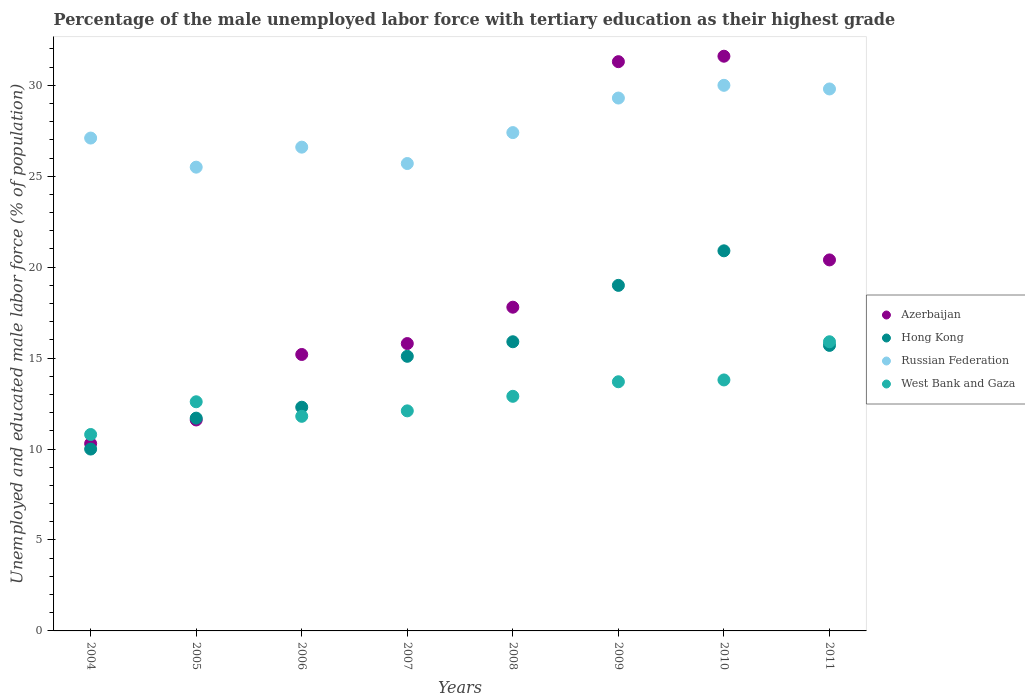Is the number of dotlines equal to the number of legend labels?
Offer a terse response. Yes. What is the percentage of the unemployed male labor force with tertiary education in Azerbaijan in 2011?
Your response must be concise. 20.4. Across all years, what is the maximum percentage of the unemployed male labor force with tertiary education in Hong Kong?
Make the answer very short. 20.9. In which year was the percentage of the unemployed male labor force with tertiary education in Hong Kong maximum?
Keep it short and to the point. 2010. What is the total percentage of the unemployed male labor force with tertiary education in Russian Federation in the graph?
Provide a succinct answer. 221.4. What is the difference between the percentage of the unemployed male labor force with tertiary education in Russian Federation in 2004 and that in 2011?
Your answer should be very brief. -2.7. What is the average percentage of the unemployed male labor force with tertiary education in West Bank and Gaza per year?
Your answer should be very brief. 12.95. In the year 2004, what is the difference between the percentage of the unemployed male labor force with tertiary education in Russian Federation and percentage of the unemployed male labor force with tertiary education in West Bank and Gaza?
Offer a very short reply. 16.3. In how many years, is the percentage of the unemployed male labor force with tertiary education in Hong Kong greater than 30 %?
Make the answer very short. 0. What is the ratio of the percentage of the unemployed male labor force with tertiary education in Azerbaijan in 2005 to that in 2008?
Offer a very short reply. 0.65. Is the percentage of the unemployed male labor force with tertiary education in Azerbaijan in 2010 less than that in 2011?
Your answer should be very brief. No. What is the difference between the highest and the second highest percentage of the unemployed male labor force with tertiary education in West Bank and Gaza?
Your answer should be very brief. 2.1. What is the difference between the highest and the lowest percentage of the unemployed male labor force with tertiary education in Hong Kong?
Your response must be concise. 10.9. In how many years, is the percentage of the unemployed male labor force with tertiary education in Hong Kong greater than the average percentage of the unemployed male labor force with tertiary education in Hong Kong taken over all years?
Make the answer very short. 5. Is the sum of the percentage of the unemployed male labor force with tertiary education in Russian Federation in 2004 and 2007 greater than the maximum percentage of the unemployed male labor force with tertiary education in Hong Kong across all years?
Make the answer very short. Yes. Is it the case that in every year, the sum of the percentage of the unemployed male labor force with tertiary education in Hong Kong and percentage of the unemployed male labor force with tertiary education in West Bank and Gaza  is greater than the percentage of the unemployed male labor force with tertiary education in Azerbaijan?
Make the answer very short. Yes. Does the percentage of the unemployed male labor force with tertiary education in Hong Kong monotonically increase over the years?
Offer a terse response. No. Is the percentage of the unemployed male labor force with tertiary education in West Bank and Gaza strictly less than the percentage of the unemployed male labor force with tertiary education in Azerbaijan over the years?
Your response must be concise. No. How many years are there in the graph?
Make the answer very short. 8. Does the graph contain grids?
Provide a short and direct response. No. How many legend labels are there?
Make the answer very short. 4. How are the legend labels stacked?
Your answer should be very brief. Vertical. What is the title of the graph?
Provide a succinct answer. Percentage of the male unemployed labor force with tertiary education as their highest grade. What is the label or title of the Y-axis?
Offer a terse response. Unemployed and educated male labor force (% of population). What is the Unemployed and educated male labor force (% of population) of Azerbaijan in 2004?
Give a very brief answer. 10.3. What is the Unemployed and educated male labor force (% of population) of Russian Federation in 2004?
Your answer should be very brief. 27.1. What is the Unemployed and educated male labor force (% of population) in West Bank and Gaza in 2004?
Your answer should be compact. 10.8. What is the Unemployed and educated male labor force (% of population) in Azerbaijan in 2005?
Provide a short and direct response. 11.6. What is the Unemployed and educated male labor force (% of population) of Hong Kong in 2005?
Keep it short and to the point. 11.7. What is the Unemployed and educated male labor force (% of population) of Russian Federation in 2005?
Keep it short and to the point. 25.5. What is the Unemployed and educated male labor force (% of population) in West Bank and Gaza in 2005?
Provide a succinct answer. 12.6. What is the Unemployed and educated male labor force (% of population) in Azerbaijan in 2006?
Give a very brief answer. 15.2. What is the Unemployed and educated male labor force (% of population) in Hong Kong in 2006?
Provide a short and direct response. 12.3. What is the Unemployed and educated male labor force (% of population) of Russian Federation in 2006?
Offer a very short reply. 26.6. What is the Unemployed and educated male labor force (% of population) of West Bank and Gaza in 2006?
Give a very brief answer. 11.8. What is the Unemployed and educated male labor force (% of population) of Azerbaijan in 2007?
Make the answer very short. 15.8. What is the Unemployed and educated male labor force (% of population) of Hong Kong in 2007?
Your answer should be very brief. 15.1. What is the Unemployed and educated male labor force (% of population) of Russian Federation in 2007?
Offer a very short reply. 25.7. What is the Unemployed and educated male labor force (% of population) in West Bank and Gaza in 2007?
Give a very brief answer. 12.1. What is the Unemployed and educated male labor force (% of population) in Azerbaijan in 2008?
Provide a short and direct response. 17.8. What is the Unemployed and educated male labor force (% of population) of Hong Kong in 2008?
Your response must be concise. 15.9. What is the Unemployed and educated male labor force (% of population) in Russian Federation in 2008?
Provide a succinct answer. 27.4. What is the Unemployed and educated male labor force (% of population) in West Bank and Gaza in 2008?
Your answer should be very brief. 12.9. What is the Unemployed and educated male labor force (% of population) of Azerbaijan in 2009?
Make the answer very short. 31.3. What is the Unemployed and educated male labor force (% of population) in Hong Kong in 2009?
Provide a short and direct response. 19. What is the Unemployed and educated male labor force (% of population) of Russian Federation in 2009?
Keep it short and to the point. 29.3. What is the Unemployed and educated male labor force (% of population) of West Bank and Gaza in 2009?
Keep it short and to the point. 13.7. What is the Unemployed and educated male labor force (% of population) of Azerbaijan in 2010?
Offer a very short reply. 31.6. What is the Unemployed and educated male labor force (% of population) of Hong Kong in 2010?
Your response must be concise. 20.9. What is the Unemployed and educated male labor force (% of population) in West Bank and Gaza in 2010?
Provide a succinct answer. 13.8. What is the Unemployed and educated male labor force (% of population) in Azerbaijan in 2011?
Provide a succinct answer. 20.4. What is the Unemployed and educated male labor force (% of population) in Hong Kong in 2011?
Offer a terse response. 15.7. What is the Unemployed and educated male labor force (% of population) in Russian Federation in 2011?
Make the answer very short. 29.8. What is the Unemployed and educated male labor force (% of population) in West Bank and Gaza in 2011?
Offer a terse response. 15.9. Across all years, what is the maximum Unemployed and educated male labor force (% of population) in Azerbaijan?
Provide a succinct answer. 31.6. Across all years, what is the maximum Unemployed and educated male labor force (% of population) of Hong Kong?
Your answer should be very brief. 20.9. Across all years, what is the maximum Unemployed and educated male labor force (% of population) in West Bank and Gaza?
Offer a terse response. 15.9. Across all years, what is the minimum Unemployed and educated male labor force (% of population) of Azerbaijan?
Give a very brief answer. 10.3. Across all years, what is the minimum Unemployed and educated male labor force (% of population) of Russian Federation?
Give a very brief answer. 25.5. Across all years, what is the minimum Unemployed and educated male labor force (% of population) of West Bank and Gaza?
Offer a terse response. 10.8. What is the total Unemployed and educated male labor force (% of population) of Azerbaijan in the graph?
Offer a terse response. 154. What is the total Unemployed and educated male labor force (% of population) of Hong Kong in the graph?
Your answer should be compact. 120.6. What is the total Unemployed and educated male labor force (% of population) of Russian Federation in the graph?
Give a very brief answer. 221.4. What is the total Unemployed and educated male labor force (% of population) of West Bank and Gaza in the graph?
Provide a succinct answer. 103.6. What is the difference between the Unemployed and educated male labor force (% of population) in Russian Federation in 2004 and that in 2005?
Provide a short and direct response. 1.6. What is the difference between the Unemployed and educated male labor force (% of population) of West Bank and Gaza in 2004 and that in 2005?
Make the answer very short. -1.8. What is the difference between the Unemployed and educated male labor force (% of population) in Azerbaijan in 2004 and that in 2006?
Give a very brief answer. -4.9. What is the difference between the Unemployed and educated male labor force (% of population) of Hong Kong in 2004 and that in 2006?
Your response must be concise. -2.3. What is the difference between the Unemployed and educated male labor force (% of population) of Russian Federation in 2004 and that in 2006?
Make the answer very short. 0.5. What is the difference between the Unemployed and educated male labor force (% of population) in Azerbaijan in 2004 and that in 2007?
Give a very brief answer. -5.5. What is the difference between the Unemployed and educated male labor force (% of population) of Russian Federation in 2004 and that in 2007?
Your answer should be very brief. 1.4. What is the difference between the Unemployed and educated male labor force (% of population) in West Bank and Gaza in 2004 and that in 2007?
Give a very brief answer. -1.3. What is the difference between the Unemployed and educated male labor force (% of population) in Russian Federation in 2004 and that in 2008?
Provide a short and direct response. -0.3. What is the difference between the Unemployed and educated male labor force (% of population) in Azerbaijan in 2004 and that in 2009?
Provide a succinct answer. -21. What is the difference between the Unemployed and educated male labor force (% of population) of Hong Kong in 2004 and that in 2009?
Your answer should be compact. -9. What is the difference between the Unemployed and educated male labor force (% of population) in Russian Federation in 2004 and that in 2009?
Your answer should be compact. -2.2. What is the difference between the Unemployed and educated male labor force (% of population) in West Bank and Gaza in 2004 and that in 2009?
Keep it short and to the point. -2.9. What is the difference between the Unemployed and educated male labor force (% of population) in Azerbaijan in 2004 and that in 2010?
Offer a terse response. -21.3. What is the difference between the Unemployed and educated male labor force (% of population) in Russian Federation in 2004 and that in 2010?
Your response must be concise. -2.9. What is the difference between the Unemployed and educated male labor force (% of population) in West Bank and Gaza in 2004 and that in 2010?
Keep it short and to the point. -3. What is the difference between the Unemployed and educated male labor force (% of population) of Azerbaijan in 2004 and that in 2011?
Give a very brief answer. -10.1. What is the difference between the Unemployed and educated male labor force (% of population) of West Bank and Gaza in 2004 and that in 2011?
Your answer should be very brief. -5.1. What is the difference between the Unemployed and educated male labor force (% of population) in Russian Federation in 2005 and that in 2006?
Provide a short and direct response. -1.1. What is the difference between the Unemployed and educated male labor force (% of population) in Azerbaijan in 2005 and that in 2007?
Offer a terse response. -4.2. What is the difference between the Unemployed and educated male labor force (% of population) of Hong Kong in 2005 and that in 2008?
Offer a very short reply. -4.2. What is the difference between the Unemployed and educated male labor force (% of population) of Russian Federation in 2005 and that in 2008?
Give a very brief answer. -1.9. What is the difference between the Unemployed and educated male labor force (% of population) of West Bank and Gaza in 2005 and that in 2008?
Ensure brevity in your answer.  -0.3. What is the difference between the Unemployed and educated male labor force (% of population) in Azerbaijan in 2005 and that in 2009?
Ensure brevity in your answer.  -19.7. What is the difference between the Unemployed and educated male labor force (% of population) in West Bank and Gaza in 2005 and that in 2009?
Keep it short and to the point. -1.1. What is the difference between the Unemployed and educated male labor force (% of population) in Hong Kong in 2005 and that in 2010?
Provide a succinct answer. -9.2. What is the difference between the Unemployed and educated male labor force (% of population) of Hong Kong in 2005 and that in 2011?
Give a very brief answer. -4. What is the difference between the Unemployed and educated male labor force (% of population) of Russian Federation in 2005 and that in 2011?
Your answer should be compact. -4.3. What is the difference between the Unemployed and educated male labor force (% of population) in Russian Federation in 2006 and that in 2007?
Ensure brevity in your answer.  0.9. What is the difference between the Unemployed and educated male labor force (% of population) in West Bank and Gaza in 2006 and that in 2007?
Provide a succinct answer. -0.3. What is the difference between the Unemployed and educated male labor force (% of population) of Hong Kong in 2006 and that in 2008?
Provide a short and direct response. -3.6. What is the difference between the Unemployed and educated male labor force (% of population) of Russian Federation in 2006 and that in 2008?
Offer a very short reply. -0.8. What is the difference between the Unemployed and educated male labor force (% of population) in Azerbaijan in 2006 and that in 2009?
Your response must be concise. -16.1. What is the difference between the Unemployed and educated male labor force (% of population) in West Bank and Gaza in 2006 and that in 2009?
Your response must be concise. -1.9. What is the difference between the Unemployed and educated male labor force (% of population) of Azerbaijan in 2006 and that in 2010?
Offer a terse response. -16.4. What is the difference between the Unemployed and educated male labor force (% of population) of Hong Kong in 2006 and that in 2010?
Your answer should be compact. -8.6. What is the difference between the Unemployed and educated male labor force (% of population) in Russian Federation in 2006 and that in 2010?
Your answer should be very brief. -3.4. What is the difference between the Unemployed and educated male labor force (% of population) of West Bank and Gaza in 2006 and that in 2010?
Offer a very short reply. -2. What is the difference between the Unemployed and educated male labor force (% of population) in Azerbaijan in 2006 and that in 2011?
Offer a terse response. -5.2. What is the difference between the Unemployed and educated male labor force (% of population) in Hong Kong in 2006 and that in 2011?
Your answer should be very brief. -3.4. What is the difference between the Unemployed and educated male labor force (% of population) in Russian Federation in 2006 and that in 2011?
Provide a succinct answer. -3.2. What is the difference between the Unemployed and educated male labor force (% of population) in West Bank and Gaza in 2006 and that in 2011?
Offer a terse response. -4.1. What is the difference between the Unemployed and educated male labor force (% of population) in Azerbaijan in 2007 and that in 2008?
Offer a very short reply. -2. What is the difference between the Unemployed and educated male labor force (% of population) in Hong Kong in 2007 and that in 2008?
Keep it short and to the point. -0.8. What is the difference between the Unemployed and educated male labor force (% of population) in West Bank and Gaza in 2007 and that in 2008?
Your answer should be compact. -0.8. What is the difference between the Unemployed and educated male labor force (% of population) in Azerbaijan in 2007 and that in 2009?
Give a very brief answer. -15.5. What is the difference between the Unemployed and educated male labor force (% of population) in West Bank and Gaza in 2007 and that in 2009?
Keep it short and to the point. -1.6. What is the difference between the Unemployed and educated male labor force (% of population) in Azerbaijan in 2007 and that in 2010?
Provide a short and direct response. -15.8. What is the difference between the Unemployed and educated male labor force (% of population) in Russian Federation in 2007 and that in 2011?
Offer a very short reply. -4.1. What is the difference between the Unemployed and educated male labor force (% of population) in Azerbaijan in 2008 and that in 2009?
Your answer should be compact. -13.5. What is the difference between the Unemployed and educated male labor force (% of population) in Hong Kong in 2008 and that in 2009?
Give a very brief answer. -3.1. What is the difference between the Unemployed and educated male labor force (% of population) of Hong Kong in 2008 and that in 2010?
Keep it short and to the point. -5. What is the difference between the Unemployed and educated male labor force (% of population) of Russian Federation in 2008 and that in 2010?
Your answer should be compact. -2.6. What is the difference between the Unemployed and educated male labor force (% of population) of West Bank and Gaza in 2008 and that in 2010?
Make the answer very short. -0.9. What is the difference between the Unemployed and educated male labor force (% of population) in Hong Kong in 2008 and that in 2011?
Make the answer very short. 0.2. What is the difference between the Unemployed and educated male labor force (% of population) in Hong Kong in 2009 and that in 2010?
Your answer should be compact. -1.9. What is the difference between the Unemployed and educated male labor force (% of population) of Russian Federation in 2009 and that in 2010?
Make the answer very short. -0.7. What is the difference between the Unemployed and educated male labor force (% of population) in West Bank and Gaza in 2009 and that in 2010?
Ensure brevity in your answer.  -0.1. What is the difference between the Unemployed and educated male labor force (% of population) in Azerbaijan in 2009 and that in 2011?
Your answer should be very brief. 10.9. What is the difference between the Unemployed and educated male labor force (% of population) in Hong Kong in 2009 and that in 2011?
Provide a succinct answer. 3.3. What is the difference between the Unemployed and educated male labor force (% of population) in Russian Federation in 2009 and that in 2011?
Your answer should be compact. -0.5. What is the difference between the Unemployed and educated male labor force (% of population) of Azerbaijan in 2010 and that in 2011?
Your response must be concise. 11.2. What is the difference between the Unemployed and educated male labor force (% of population) in Russian Federation in 2010 and that in 2011?
Your response must be concise. 0.2. What is the difference between the Unemployed and educated male labor force (% of population) in West Bank and Gaza in 2010 and that in 2011?
Make the answer very short. -2.1. What is the difference between the Unemployed and educated male labor force (% of population) in Azerbaijan in 2004 and the Unemployed and educated male labor force (% of population) in Hong Kong in 2005?
Offer a terse response. -1.4. What is the difference between the Unemployed and educated male labor force (% of population) of Azerbaijan in 2004 and the Unemployed and educated male labor force (% of population) of Russian Federation in 2005?
Keep it short and to the point. -15.2. What is the difference between the Unemployed and educated male labor force (% of population) of Hong Kong in 2004 and the Unemployed and educated male labor force (% of population) of Russian Federation in 2005?
Provide a succinct answer. -15.5. What is the difference between the Unemployed and educated male labor force (% of population) in Hong Kong in 2004 and the Unemployed and educated male labor force (% of population) in West Bank and Gaza in 2005?
Your response must be concise. -2.6. What is the difference between the Unemployed and educated male labor force (% of population) in Russian Federation in 2004 and the Unemployed and educated male labor force (% of population) in West Bank and Gaza in 2005?
Your answer should be very brief. 14.5. What is the difference between the Unemployed and educated male labor force (% of population) in Azerbaijan in 2004 and the Unemployed and educated male labor force (% of population) in Hong Kong in 2006?
Offer a very short reply. -2. What is the difference between the Unemployed and educated male labor force (% of population) of Azerbaijan in 2004 and the Unemployed and educated male labor force (% of population) of Russian Federation in 2006?
Your answer should be compact. -16.3. What is the difference between the Unemployed and educated male labor force (% of population) of Azerbaijan in 2004 and the Unemployed and educated male labor force (% of population) of West Bank and Gaza in 2006?
Your response must be concise. -1.5. What is the difference between the Unemployed and educated male labor force (% of population) in Hong Kong in 2004 and the Unemployed and educated male labor force (% of population) in Russian Federation in 2006?
Ensure brevity in your answer.  -16.6. What is the difference between the Unemployed and educated male labor force (% of population) in Azerbaijan in 2004 and the Unemployed and educated male labor force (% of population) in Russian Federation in 2007?
Make the answer very short. -15.4. What is the difference between the Unemployed and educated male labor force (% of population) of Azerbaijan in 2004 and the Unemployed and educated male labor force (% of population) of West Bank and Gaza in 2007?
Offer a terse response. -1.8. What is the difference between the Unemployed and educated male labor force (% of population) of Hong Kong in 2004 and the Unemployed and educated male labor force (% of population) of Russian Federation in 2007?
Your answer should be very brief. -15.7. What is the difference between the Unemployed and educated male labor force (% of population) in Hong Kong in 2004 and the Unemployed and educated male labor force (% of population) in West Bank and Gaza in 2007?
Offer a terse response. -2.1. What is the difference between the Unemployed and educated male labor force (% of population) in Azerbaijan in 2004 and the Unemployed and educated male labor force (% of population) in Russian Federation in 2008?
Provide a short and direct response. -17.1. What is the difference between the Unemployed and educated male labor force (% of population) in Hong Kong in 2004 and the Unemployed and educated male labor force (% of population) in Russian Federation in 2008?
Provide a short and direct response. -17.4. What is the difference between the Unemployed and educated male labor force (% of population) in Hong Kong in 2004 and the Unemployed and educated male labor force (% of population) in West Bank and Gaza in 2008?
Make the answer very short. -2.9. What is the difference between the Unemployed and educated male labor force (% of population) of Azerbaijan in 2004 and the Unemployed and educated male labor force (% of population) of Russian Federation in 2009?
Give a very brief answer. -19. What is the difference between the Unemployed and educated male labor force (% of population) in Hong Kong in 2004 and the Unemployed and educated male labor force (% of population) in Russian Federation in 2009?
Offer a very short reply. -19.3. What is the difference between the Unemployed and educated male labor force (% of population) in Russian Federation in 2004 and the Unemployed and educated male labor force (% of population) in West Bank and Gaza in 2009?
Provide a short and direct response. 13.4. What is the difference between the Unemployed and educated male labor force (% of population) in Azerbaijan in 2004 and the Unemployed and educated male labor force (% of population) in Hong Kong in 2010?
Give a very brief answer. -10.6. What is the difference between the Unemployed and educated male labor force (% of population) in Azerbaijan in 2004 and the Unemployed and educated male labor force (% of population) in Russian Federation in 2010?
Offer a terse response. -19.7. What is the difference between the Unemployed and educated male labor force (% of population) of Azerbaijan in 2004 and the Unemployed and educated male labor force (% of population) of West Bank and Gaza in 2010?
Provide a succinct answer. -3.5. What is the difference between the Unemployed and educated male labor force (% of population) of Hong Kong in 2004 and the Unemployed and educated male labor force (% of population) of Russian Federation in 2010?
Keep it short and to the point. -20. What is the difference between the Unemployed and educated male labor force (% of population) of Azerbaijan in 2004 and the Unemployed and educated male labor force (% of population) of Russian Federation in 2011?
Offer a terse response. -19.5. What is the difference between the Unemployed and educated male labor force (% of population) of Hong Kong in 2004 and the Unemployed and educated male labor force (% of population) of Russian Federation in 2011?
Ensure brevity in your answer.  -19.8. What is the difference between the Unemployed and educated male labor force (% of population) of Russian Federation in 2004 and the Unemployed and educated male labor force (% of population) of West Bank and Gaza in 2011?
Ensure brevity in your answer.  11.2. What is the difference between the Unemployed and educated male labor force (% of population) of Azerbaijan in 2005 and the Unemployed and educated male labor force (% of population) of West Bank and Gaza in 2006?
Ensure brevity in your answer.  -0.2. What is the difference between the Unemployed and educated male labor force (% of population) of Hong Kong in 2005 and the Unemployed and educated male labor force (% of population) of Russian Federation in 2006?
Your answer should be very brief. -14.9. What is the difference between the Unemployed and educated male labor force (% of population) in Hong Kong in 2005 and the Unemployed and educated male labor force (% of population) in West Bank and Gaza in 2006?
Ensure brevity in your answer.  -0.1. What is the difference between the Unemployed and educated male labor force (% of population) in Azerbaijan in 2005 and the Unemployed and educated male labor force (% of population) in Hong Kong in 2007?
Make the answer very short. -3.5. What is the difference between the Unemployed and educated male labor force (% of population) of Azerbaijan in 2005 and the Unemployed and educated male labor force (% of population) of Russian Federation in 2007?
Your answer should be compact. -14.1. What is the difference between the Unemployed and educated male labor force (% of population) of Azerbaijan in 2005 and the Unemployed and educated male labor force (% of population) of West Bank and Gaza in 2007?
Provide a succinct answer. -0.5. What is the difference between the Unemployed and educated male labor force (% of population) of Azerbaijan in 2005 and the Unemployed and educated male labor force (% of population) of Hong Kong in 2008?
Keep it short and to the point. -4.3. What is the difference between the Unemployed and educated male labor force (% of population) in Azerbaijan in 2005 and the Unemployed and educated male labor force (% of population) in Russian Federation in 2008?
Offer a very short reply. -15.8. What is the difference between the Unemployed and educated male labor force (% of population) of Azerbaijan in 2005 and the Unemployed and educated male labor force (% of population) of West Bank and Gaza in 2008?
Provide a succinct answer. -1.3. What is the difference between the Unemployed and educated male labor force (% of population) in Hong Kong in 2005 and the Unemployed and educated male labor force (% of population) in Russian Federation in 2008?
Offer a very short reply. -15.7. What is the difference between the Unemployed and educated male labor force (% of population) in Azerbaijan in 2005 and the Unemployed and educated male labor force (% of population) in Russian Federation in 2009?
Provide a short and direct response. -17.7. What is the difference between the Unemployed and educated male labor force (% of population) of Azerbaijan in 2005 and the Unemployed and educated male labor force (% of population) of West Bank and Gaza in 2009?
Your answer should be compact. -2.1. What is the difference between the Unemployed and educated male labor force (% of population) in Hong Kong in 2005 and the Unemployed and educated male labor force (% of population) in Russian Federation in 2009?
Provide a short and direct response. -17.6. What is the difference between the Unemployed and educated male labor force (% of population) in Hong Kong in 2005 and the Unemployed and educated male labor force (% of population) in West Bank and Gaza in 2009?
Offer a very short reply. -2. What is the difference between the Unemployed and educated male labor force (% of population) in Russian Federation in 2005 and the Unemployed and educated male labor force (% of population) in West Bank and Gaza in 2009?
Offer a terse response. 11.8. What is the difference between the Unemployed and educated male labor force (% of population) in Azerbaijan in 2005 and the Unemployed and educated male labor force (% of population) in Hong Kong in 2010?
Provide a short and direct response. -9.3. What is the difference between the Unemployed and educated male labor force (% of population) in Azerbaijan in 2005 and the Unemployed and educated male labor force (% of population) in Russian Federation in 2010?
Your answer should be very brief. -18.4. What is the difference between the Unemployed and educated male labor force (% of population) of Azerbaijan in 2005 and the Unemployed and educated male labor force (% of population) of West Bank and Gaza in 2010?
Offer a terse response. -2.2. What is the difference between the Unemployed and educated male labor force (% of population) in Hong Kong in 2005 and the Unemployed and educated male labor force (% of population) in Russian Federation in 2010?
Provide a short and direct response. -18.3. What is the difference between the Unemployed and educated male labor force (% of population) of Russian Federation in 2005 and the Unemployed and educated male labor force (% of population) of West Bank and Gaza in 2010?
Keep it short and to the point. 11.7. What is the difference between the Unemployed and educated male labor force (% of population) of Azerbaijan in 2005 and the Unemployed and educated male labor force (% of population) of Hong Kong in 2011?
Offer a terse response. -4.1. What is the difference between the Unemployed and educated male labor force (% of population) in Azerbaijan in 2005 and the Unemployed and educated male labor force (% of population) in Russian Federation in 2011?
Your response must be concise. -18.2. What is the difference between the Unemployed and educated male labor force (% of population) in Hong Kong in 2005 and the Unemployed and educated male labor force (% of population) in Russian Federation in 2011?
Your answer should be compact. -18.1. What is the difference between the Unemployed and educated male labor force (% of population) of Hong Kong in 2005 and the Unemployed and educated male labor force (% of population) of West Bank and Gaza in 2011?
Make the answer very short. -4.2. What is the difference between the Unemployed and educated male labor force (% of population) of Azerbaijan in 2006 and the Unemployed and educated male labor force (% of population) of Hong Kong in 2007?
Your response must be concise. 0.1. What is the difference between the Unemployed and educated male labor force (% of population) in Azerbaijan in 2006 and the Unemployed and educated male labor force (% of population) in Russian Federation in 2007?
Provide a succinct answer. -10.5. What is the difference between the Unemployed and educated male labor force (% of population) of Azerbaijan in 2006 and the Unemployed and educated male labor force (% of population) of West Bank and Gaza in 2007?
Your answer should be very brief. 3.1. What is the difference between the Unemployed and educated male labor force (% of population) of Hong Kong in 2006 and the Unemployed and educated male labor force (% of population) of Russian Federation in 2007?
Offer a terse response. -13.4. What is the difference between the Unemployed and educated male labor force (% of population) of Russian Federation in 2006 and the Unemployed and educated male labor force (% of population) of West Bank and Gaza in 2007?
Make the answer very short. 14.5. What is the difference between the Unemployed and educated male labor force (% of population) of Azerbaijan in 2006 and the Unemployed and educated male labor force (% of population) of Hong Kong in 2008?
Provide a succinct answer. -0.7. What is the difference between the Unemployed and educated male labor force (% of population) of Hong Kong in 2006 and the Unemployed and educated male labor force (% of population) of Russian Federation in 2008?
Your answer should be very brief. -15.1. What is the difference between the Unemployed and educated male labor force (% of population) in Hong Kong in 2006 and the Unemployed and educated male labor force (% of population) in West Bank and Gaza in 2008?
Offer a very short reply. -0.6. What is the difference between the Unemployed and educated male labor force (% of population) in Azerbaijan in 2006 and the Unemployed and educated male labor force (% of population) in Hong Kong in 2009?
Your answer should be compact. -3.8. What is the difference between the Unemployed and educated male labor force (% of population) in Azerbaijan in 2006 and the Unemployed and educated male labor force (% of population) in Russian Federation in 2009?
Your answer should be very brief. -14.1. What is the difference between the Unemployed and educated male labor force (% of population) in Azerbaijan in 2006 and the Unemployed and educated male labor force (% of population) in West Bank and Gaza in 2009?
Your answer should be compact. 1.5. What is the difference between the Unemployed and educated male labor force (% of population) in Russian Federation in 2006 and the Unemployed and educated male labor force (% of population) in West Bank and Gaza in 2009?
Your answer should be compact. 12.9. What is the difference between the Unemployed and educated male labor force (% of population) in Azerbaijan in 2006 and the Unemployed and educated male labor force (% of population) in Russian Federation in 2010?
Provide a short and direct response. -14.8. What is the difference between the Unemployed and educated male labor force (% of population) of Azerbaijan in 2006 and the Unemployed and educated male labor force (% of population) of West Bank and Gaza in 2010?
Give a very brief answer. 1.4. What is the difference between the Unemployed and educated male labor force (% of population) in Hong Kong in 2006 and the Unemployed and educated male labor force (% of population) in Russian Federation in 2010?
Your answer should be very brief. -17.7. What is the difference between the Unemployed and educated male labor force (% of population) in Hong Kong in 2006 and the Unemployed and educated male labor force (% of population) in West Bank and Gaza in 2010?
Your answer should be compact. -1.5. What is the difference between the Unemployed and educated male labor force (% of population) of Azerbaijan in 2006 and the Unemployed and educated male labor force (% of population) of Russian Federation in 2011?
Offer a very short reply. -14.6. What is the difference between the Unemployed and educated male labor force (% of population) in Hong Kong in 2006 and the Unemployed and educated male labor force (% of population) in Russian Federation in 2011?
Your answer should be very brief. -17.5. What is the difference between the Unemployed and educated male labor force (% of population) in Russian Federation in 2006 and the Unemployed and educated male labor force (% of population) in West Bank and Gaza in 2011?
Give a very brief answer. 10.7. What is the difference between the Unemployed and educated male labor force (% of population) in Azerbaijan in 2007 and the Unemployed and educated male labor force (% of population) in Hong Kong in 2008?
Offer a terse response. -0.1. What is the difference between the Unemployed and educated male labor force (% of population) in Azerbaijan in 2007 and the Unemployed and educated male labor force (% of population) in West Bank and Gaza in 2008?
Your answer should be compact. 2.9. What is the difference between the Unemployed and educated male labor force (% of population) in Hong Kong in 2007 and the Unemployed and educated male labor force (% of population) in Russian Federation in 2008?
Provide a succinct answer. -12.3. What is the difference between the Unemployed and educated male labor force (% of population) in Azerbaijan in 2007 and the Unemployed and educated male labor force (% of population) in Hong Kong in 2009?
Give a very brief answer. -3.2. What is the difference between the Unemployed and educated male labor force (% of population) in Hong Kong in 2007 and the Unemployed and educated male labor force (% of population) in West Bank and Gaza in 2009?
Your answer should be compact. 1.4. What is the difference between the Unemployed and educated male labor force (% of population) in Russian Federation in 2007 and the Unemployed and educated male labor force (% of population) in West Bank and Gaza in 2009?
Make the answer very short. 12. What is the difference between the Unemployed and educated male labor force (% of population) in Azerbaijan in 2007 and the Unemployed and educated male labor force (% of population) in Hong Kong in 2010?
Make the answer very short. -5.1. What is the difference between the Unemployed and educated male labor force (% of population) in Azerbaijan in 2007 and the Unemployed and educated male labor force (% of population) in West Bank and Gaza in 2010?
Keep it short and to the point. 2. What is the difference between the Unemployed and educated male labor force (% of population) in Hong Kong in 2007 and the Unemployed and educated male labor force (% of population) in Russian Federation in 2010?
Provide a short and direct response. -14.9. What is the difference between the Unemployed and educated male labor force (% of population) in Hong Kong in 2007 and the Unemployed and educated male labor force (% of population) in West Bank and Gaza in 2010?
Ensure brevity in your answer.  1.3. What is the difference between the Unemployed and educated male labor force (% of population) in Russian Federation in 2007 and the Unemployed and educated male labor force (% of population) in West Bank and Gaza in 2010?
Offer a very short reply. 11.9. What is the difference between the Unemployed and educated male labor force (% of population) in Azerbaijan in 2007 and the Unemployed and educated male labor force (% of population) in Russian Federation in 2011?
Your answer should be compact. -14. What is the difference between the Unemployed and educated male labor force (% of population) in Azerbaijan in 2007 and the Unemployed and educated male labor force (% of population) in West Bank and Gaza in 2011?
Your answer should be very brief. -0.1. What is the difference between the Unemployed and educated male labor force (% of population) in Hong Kong in 2007 and the Unemployed and educated male labor force (% of population) in Russian Federation in 2011?
Make the answer very short. -14.7. What is the difference between the Unemployed and educated male labor force (% of population) of Azerbaijan in 2008 and the Unemployed and educated male labor force (% of population) of Russian Federation in 2009?
Make the answer very short. -11.5. What is the difference between the Unemployed and educated male labor force (% of population) in Azerbaijan in 2008 and the Unemployed and educated male labor force (% of population) in West Bank and Gaza in 2009?
Your response must be concise. 4.1. What is the difference between the Unemployed and educated male labor force (% of population) in Hong Kong in 2008 and the Unemployed and educated male labor force (% of population) in Russian Federation in 2009?
Provide a succinct answer. -13.4. What is the difference between the Unemployed and educated male labor force (% of population) of Hong Kong in 2008 and the Unemployed and educated male labor force (% of population) of West Bank and Gaza in 2009?
Offer a terse response. 2.2. What is the difference between the Unemployed and educated male labor force (% of population) of Russian Federation in 2008 and the Unemployed and educated male labor force (% of population) of West Bank and Gaza in 2009?
Provide a short and direct response. 13.7. What is the difference between the Unemployed and educated male labor force (% of population) of Azerbaijan in 2008 and the Unemployed and educated male labor force (% of population) of West Bank and Gaza in 2010?
Your answer should be compact. 4. What is the difference between the Unemployed and educated male labor force (% of population) in Hong Kong in 2008 and the Unemployed and educated male labor force (% of population) in Russian Federation in 2010?
Offer a terse response. -14.1. What is the difference between the Unemployed and educated male labor force (% of population) in Hong Kong in 2008 and the Unemployed and educated male labor force (% of population) in West Bank and Gaza in 2010?
Your response must be concise. 2.1. What is the difference between the Unemployed and educated male labor force (% of population) of Azerbaijan in 2008 and the Unemployed and educated male labor force (% of population) of Hong Kong in 2011?
Your response must be concise. 2.1. What is the difference between the Unemployed and educated male labor force (% of population) of Azerbaijan in 2009 and the Unemployed and educated male labor force (% of population) of Russian Federation in 2010?
Keep it short and to the point. 1.3. What is the difference between the Unemployed and educated male labor force (% of population) in Hong Kong in 2009 and the Unemployed and educated male labor force (% of population) in West Bank and Gaza in 2010?
Make the answer very short. 5.2. What is the difference between the Unemployed and educated male labor force (% of population) of Azerbaijan in 2009 and the Unemployed and educated male labor force (% of population) of Hong Kong in 2011?
Provide a short and direct response. 15.6. What is the difference between the Unemployed and educated male labor force (% of population) in Hong Kong in 2009 and the Unemployed and educated male labor force (% of population) in West Bank and Gaza in 2011?
Offer a very short reply. 3.1. What is the difference between the Unemployed and educated male labor force (% of population) in Russian Federation in 2009 and the Unemployed and educated male labor force (% of population) in West Bank and Gaza in 2011?
Your response must be concise. 13.4. What is the difference between the Unemployed and educated male labor force (% of population) of Azerbaijan in 2010 and the Unemployed and educated male labor force (% of population) of Russian Federation in 2011?
Your answer should be very brief. 1.8. What is the difference between the Unemployed and educated male labor force (% of population) of Hong Kong in 2010 and the Unemployed and educated male labor force (% of population) of West Bank and Gaza in 2011?
Give a very brief answer. 5. What is the difference between the Unemployed and educated male labor force (% of population) of Russian Federation in 2010 and the Unemployed and educated male labor force (% of population) of West Bank and Gaza in 2011?
Make the answer very short. 14.1. What is the average Unemployed and educated male labor force (% of population) of Azerbaijan per year?
Ensure brevity in your answer.  19.25. What is the average Unemployed and educated male labor force (% of population) of Hong Kong per year?
Your response must be concise. 15.07. What is the average Unemployed and educated male labor force (% of population) of Russian Federation per year?
Offer a very short reply. 27.68. What is the average Unemployed and educated male labor force (% of population) in West Bank and Gaza per year?
Provide a succinct answer. 12.95. In the year 2004, what is the difference between the Unemployed and educated male labor force (% of population) in Azerbaijan and Unemployed and educated male labor force (% of population) in Russian Federation?
Make the answer very short. -16.8. In the year 2004, what is the difference between the Unemployed and educated male labor force (% of population) of Hong Kong and Unemployed and educated male labor force (% of population) of Russian Federation?
Keep it short and to the point. -17.1. In the year 2005, what is the difference between the Unemployed and educated male labor force (% of population) in Azerbaijan and Unemployed and educated male labor force (% of population) in West Bank and Gaza?
Your answer should be compact. -1. In the year 2006, what is the difference between the Unemployed and educated male labor force (% of population) of Azerbaijan and Unemployed and educated male labor force (% of population) of Hong Kong?
Your answer should be compact. 2.9. In the year 2006, what is the difference between the Unemployed and educated male labor force (% of population) in Azerbaijan and Unemployed and educated male labor force (% of population) in Russian Federation?
Offer a terse response. -11.4. In the year 2006, what is the difference between the Unemployed and educated male labor force (% of population) of Azerbaijan and Unemployed and educated male labor force (% of population) of West Bank and Gaza?
Your answer should be compact. 3.4. In the year 2006, what is the difference between the Unemployed and educated male labor force (% of population) in Hong Kong and Unemployed and educated male labor force (% of population) in Russian Federation?
Make the answer very short. -14.3. In the year 2006, what is the difference between the Unemployed and educated male labor force (% of population) in Russian Federation and Unemployed and educated male labor force (% of population) in West Bank and Gaza?
Your answer should be very brief. 14.8. In the year 2008, what is the difference between the Unemployed and educated male labor force (% of population) of Azerbaijan and Unemployed and educated male labor force (% of population) of Russian Federation?
Your answer should be very brief. -9.6. In the year 2008, what is the difference between the Unemployed and educated male labor force (% of population) of Hong Kong and Unemployed and educated male labor force (% of population) of West Bank and Gaza?
Provide a succinct answer. 3. In the year 2009, what is the difference between the Unemployed and educated male labor force (% of population) in Azerbaijan and Unemployed and educated male labor force (% of population) in Russian Federation?
Ensure brevity in your answer.  2. In the year 2009, what is the difference between the Unemployed and educated male labor force (% of population) in Hong Kong and Unemployed and educated male labor force (% of population) in Russian Federation?
Offer a terse response. -10.3. In the year 2009, what is the difference between the Unemployed and educated male labor force (% of population) of Russian Federation and Unemployed and educated male labor force (% of population) of West Bank and Gaza?
Make the answer very short. 15.6. In the year 2010, what is the difference between the Unemployed and educated male labor force (% of population) of Azerbaijan and Unemployed and educated male labor force (% of population) of West Bank and Gaza?
Offer a terse response. 17.8. In the year 2010, what is the difference between the Unemployed and educated male labor force (% of population) of Russian Federation and Unemployed and educated male labor force (% of population) of West Bank and Gaza?
Ensure brevity in your answer.  16.2. In the year 2011, what is the difference between the Unemployed and educated male labor force (% of population) in Azerbaijan and Unemployed and educated male labor force (% of population) in Hong Kong?
Your response must be concise. 4.7. In the year 2011, what is the difference between the Unemployed and educated male labor force (% of population) of Hong Kong and Unemployed and educated male labor force (% of population) of Russian Federation?
Your answer should be compact. -14.1. In the year 2011, what is the difference between the Unemployed and educated male labor force (% of population) of Hong Kong and Unemployed and educated male labor force (% of population) of West Bank and Gaza?
Ensure brevity in your answer.  -0.2. In the year 2011, what is the difference between the Unemployed and educated male labor force (% of population) of Russian Federation and Unemployed and educated male labor force (% of population) of West Bank and Gaza?
Offer a very short reply. 13.9. What is the ratio of the Unemployed and educated male labor force (% of population) in Azerbaijan in 2004 to that in 2005?
Your answer should be very brief. 0.89. What is the ratio of the Unemployed and educated male labor force (% of population) in Hong Kong in 2004 to that in 2005?
Ensure brevity in your answer.  0.85. What is the ratio of the Unemployed and educated male labor force (% of population) of Russian Federation in 2004 to that in 2005?
Make the answer very short. 1.06. What is the ratio of the Unemployed and educated male labor force (% of population) in West Bank and Gaza in 2004 to that in 2005?
Give a very brief answer. 0.86. What is the ratio of the Unemployed and educated male labor force (% of population) in Azerbaijan in 2004 to that in 2006?
Make the answer very short. 0.68. What is the ratio of the Unemployed and educated male labor force (% of population) of Hong Kong in 2004 to that in 2006?
Your response must be concise. 0.81. What is the ratio of the Unemployed and educated male labor force (% of population) of Russian Federation in 2004 to that in 2006?
Provide a succinct answer. 1.02. What is the ratio of the Unemployed and educated male labor force (% of population) of West Bank and Gaza in 2004 to that in 2006?
Offer a very short reply. 0.92. What is the ratio of the Unemployed and educated male labor force (% of population) of Azerbaijan in 2004 to that in 2007?
Offer a terse response. 0.65. What is the ratio of the Unemployed and educated male labor force (% of population) of Hong Kong in 2004 to that in 2007?
Provide a succinct answer. 0.66. What is the ratio of the Unemployed and educated male labor force (% of population) of Russian Federation in 2004 to that in 2007?
Your response must be concise. 1.05. What is the ratio of the Unemployed and educated male labor force (% of population) of West Bank and Gaza in 2004 to that in 2007?
Keep it short and to the point. 0.89. What is the ratio of the Unemployed and educated male labor force (% of population) in Azerbaijan in 2004 to that in 2008?
Provide a short and direct response. 0.58. What is the ratio of the Unemployed and educated male labor force (% of population) in Hong Kong in 2004 to that in 2008?
Offer a terse response. 0.63. What is the ratio of the Unemployed and educated male labor force (% of population) in Russian Federation in 2004 to that in 2008?
Make the answer very short. 0.99. What is the ratio of the Unemployed and educated male labor force (% of population) of West Bank and Gaza in 2004 to that in 2008?
Provide a short and direct response. 0.84. What is the ratio of the Unemployed and educated male labor force (% of population) of Azerbaijan in 2004 to that in 2009?
Make the answer very short. 0.33. What is the ratio of the Unemployed and educated male labor force (% of population) of Hong Kong in 2004 to that in 2009?
Your answer should be compact. 0.53. What is the ratio of the Unemployed and educated male labor force (% of population) of Russian Federation in 2004 to that in 2009?
Provide a succinct answer. 0.92. What is the ratio of the Unemployed and educated male labor force (% of population) in West Bank and Gaza in 2004 to that in 2009?
Offer a very short reply. 0.79. What is the ratio of the Unemployed and educated male labor force (% of population) of Azerbaijan in 2004 to that in 2010?
Offer a very short reply. 0.33. What is the ratio of the Unemployed and educated male labor force (% of population) of Hong Kong in 2004 to that in 2010?
Ensure brevity in your answer.  0.48. What is the ratio of the Unemployed and educated male labor force (% of population) of Russian Federation in 2004 to that in 2010?
Make the answer very short. 0.9. What is the ratio of the Unemployed and educated male labor force (% of population) of West Bank and Gaza in 2004 to that in 2010?
Provide a short and direct response. 0.78. What is the ratio of the Unemployed and educated male labor force (% of population) in Azerbaijan in 2004 to that in 2011?
Provide a succinct answer. 0.5. What is the ratio of the Unemployed and educated male labor force (% of population) in Hong Kong in 2004 to that in 2011?
Provide a succinct answer. 0.64. What is the ratio of the Unemployed and educated male labor force (% of population) in Russian Federation in 2004 to that in 2011?
Provide a short and direct response. 0.91. What is the ratio of the Unemployed and educated male labor force (% of population) of West Bank and Gaza in 2004 to that in 2011?
Offer a very short reply. 0.68. What is the ratio of the Unemployed and educated male labor force (% of population) of Azerbaijan in 2005 to that in 2006?
Provide a succinct answer. 0.76. What is the ratio of the Unemployed and educated male labor force (% of population) in Hong Kong in 2005 to that in 2006?
Offer a terse response. 0.95. What is the ratio of the Unemployed and educated male labor force (% of population) of Russian Federation in 2005 to that in 2006?
Keep it short and to the point. 0.96. What is the ratio of the Unemployed and educated male labor force (% of population) of West Bank and Gaza in 2005 to that in 2006?
Your response must be concise. 1.07. What is the ratio of the Unemployed and educated male labor force (% of population) in Azerbaijan in 2005 to that in 2007?
Your answer should be compact. 0.73. What is the ratio of the Unemployed and educated male labor force (% of population) of Hong Kong in 2005 to that in 2007?
Provide a succinct answer. 0.77. What is the ratio of the Unemployed and educated male labor force (% of population) of West Bank and Gaza in 2005 to that in 2007?
Offer a terse response. 1.04. What is the ratio of the Unemployed and educated male labor force (% of population) in Azerbaijan in 2005 to that in 2008?
Provide a succinct answer. 0.65. What is the ratio of the Unemployed and educated male labor force (% of population) of Hong Kong in 2005 to that in 2008?
Make the answer very short. 0.74. What is the ratio of the Unemployed and educated male labor force (% of population) in Russian Federation in 2005 to that in 2008?
Your answer should be compact. 0.93. What is the ratio of the Unemployed and educated male labor force (% of population) in West Bank and Gaza in 2005 to that in 2008?
Your answer should be very brief. 0.98. What is the ratio of the Unemployed and educated male labor force (% of population) in Azerbaijan in 2005 to that in 2009?
Make the answer very short. 0.37. What is the ratio of the Unemployed and educated male labor force (% of population) in Hong Kong in 2005 to that in 2009?
Your answer should be very brief. 0.62. What is the ratio of the Unemployed and educated male labor force (% of population) of Russian Federation in 2005 to that in 2009?
Ensure brevity in your answer.  0.87. What is the ratio of the Unemployed and educated male labor force (% of population) in West Bank and Gaza in 2005 to that in 2009?
Your answer should be very brief. 0.92. What is the ratio of the Unemployed and educated male labor force (% of population) in Azerbaijan in 2005 to that in 2010?
Provide a succinct answer. 0.37. What is the ratio of the Unemployed and educated male labor force (% of population) of Hong Kong in 2005 to that in 2010?
Offer a very short reply. 0.56. What is the ratio of the Unemployed and educated male labor force (% of population) of Azerbaijan in 2005 to that in 2011?
Offer a terse response. 0.57. What is the ratio of the Unemployed and educated male labor force (% of population) of Hong Kong in 2005 to that in 2011?
Your response must be concise. 0.75. What is the ratio of the Unemployed and educated male labor force (% of population) of Russian Federation in 2005 to that in 2011?
Make the answer very short. 0.86. What is the ratio of the Unemployed and educated male labor force (% of population) in West Bank and Gaza in 2005 to that in 2011?
Give a very brief answer. 0.79. What is the ratio of the Unemployed and educated male labor force (% of population) of Hong Kong in 2006 to that in 2007?
Provide a succinct answer. 0.81. What is the ratio of the Unemployed and educated male labor force (% of population) of Russian Federation in 2006 to that in 2007?
Offer a terse response. 1.03. What is the ratio of the Unemployed and educated male labor force (% of population) in West Bank and Gaza in 2006 to that in 2007?
Ensure brevity in your answer.  0.98. What is the ratio of the Unemployed and educated male labor force (% of population) in Azerbaijan in 2006 to that in 2008?
Provide a short and direct response. 0.85. What is the ratio of the Unemployed and educated male labor force (% of population) of Hong Kong in 2006 to that in 2008?
Your answer should be very brief. 0.77. What is the ratio of the Unemployed and educated male labor force (% of population) in Russian Federation in 2006 to that in 2008?
Ensure brevity in your answer.  0.97. What is the ratio of the Unemployed and educated male labor force (% of population) in West Bank and Gaza in 2006 to that in 2008?
Offer a very short reply. 0.91. What is the ratio of the Unemployed and educated male labor force (% of population) in Azerbaijan in 2006 to that in 2009?
Make the answer very short. 0.49. What is the ratio of the Unemployed and educated male labor force (% of population) in Hong Kong in 2006 to that in 2009?
Your answer should be very brief. 0.65. What is the ratio of the Unemployed and educated male labor force (% of population) in Russian Federation in 2006 to that in 2009?
Your answer should be compact. 0.91. What is the ratio of the Unemployed and educated male labor force (% of population) of West Bank and Gaza in 2006 to that in 2009?
Your answer should be compact. 0.86. What is the ratio of the Unemployed and educated male labor force (% of population) in Azerbaijan in 2006 to that in 2010?
Your answer should be compact. 0.48. What is the ratio of the Unemployed and educated male labor force (% of population) in Hong Kong in 2006 to that in 2010?
Offer a very short reply. 0.59. What is the ratio of the Unemployed and educated male labor force (% of population) of Russian Federation in 2006 to that in 2010?
Provide a succinct answer. 0.89. What is the ratio of the Unemployed and educated male labor force (% of population) of West Bank and Gaza in 2006 to that in 2010?
Offer a very short reply. 0.86. What is the ratio of the Unemployed and educated male labor force (% of population) in Azerbaijan in 2006 to that in 2011?
Provide a short and direct response. 0.75. What is the ratio of the Unemployed and educated male labor force (% of population) of Hong Kong in 2006 to that in 2011?
Your answer should be very brief. 0.78. What is the ratio of the Unemployed and educated male labor force (% of population) of Russian Federation in 2006 to that in 2011?
Make the answer very short. 0.89. What is the ratio of the Unemployed and educated male labor force (% of population) in West Bank and Gaza in 2006 to that in 2011?
Ensure brevity in your answer.  0.74. What is the ratio of the Unemployed and educated male labor force (% of population) of Azerbaijan in 2007 to that in 2008?
Make the answer very short. 0.89. What is the ratio of the Unemployed and educated male labor force (% of population) of Hong Kong in 2007 to that in 2008?
Make the answer very short. 0.95. What is the ratio of the Unemployed and educated male labor force (% of population) of Russian Federation in 2007 to that in 2008?
Your response must be concise. 0.94. What is the ratio of the Unemployed and educated male labor force (% of population) of West Bank and Gaza in 2007 to that in 2008?
Your response must be concise. 0.94. What is the ratio of the Unemployed and educated male labor force (% of population) in Azerbaijan in 2007 to that in 2009?
Offer a terse response. 0.5. What is the ratio of the Unemployed and educated male labor force (% of population) of Hong Kong in 2007 to that in 2009?
Make the answer very short. 0.79. What is the ratio of the Unemployed and educated male labor force (% of population) in Russian Federation in 2007 to that in 2009?
Your answer should be compact. 0.88. What is the ratio of the Unemployed and educated male labor force (% of population) of West Bank and Gaza in 2007 to that in 2009?
Provide a succinct answer. 0.88. What is the ratio of the Unemployed and educated male labor force (% of population) of Azerbaijan in 2007 to that in 2010?
Provide a succinct answer. 0.5. What is the ratio of the Unemployed and educated male labor force (% of population) of Hong Kong in 2007 to that in 2010?
Offer a very short reply. 0.72. What is the ratio of the Unemployed and educated male labor force (% of population) of Russian Federation in 2007 to that in 2010?
Offer a very short reply. 0.86. What is the ratio of the Unemployed and educated male labor force (% of population) in West Bank and Gaza in 2007 to that in 2010?
Offer a terse response. 0.88. What is the ratio of the Unemployed and educated male labor force (% of population) in Azerbaijan in 2007 to that in 2011?
Your answer should be compact. 0.77. What is the ratio of the Unemployed and educated male labor force (% of population) of Hong Kong in 2007 to that in 2011?
Offer a terse response. 0.96. What is the ratio of the Unemployed and educated male labor force (% of population) in Russian Federation in 2007 to that in 2011?
Keep it short and to the point. 0.86. What is the ratio of the Unemployed and educated male labor force (% of population) of West Bank and Gaza in 2007 to that in 2011?
Your answer should be very brief. 0.76. What is the ratio of the Unemployed and educated male labor force (% of population) in Azerbaijan in 2008 to that in 2009?
Your answer should be compact. 0.57. What is the ratio of the Unemployed and educated male labor force (% of population) of Hong Kong in 2008 to that in 2009?
Give a very brief answer. 0.84. What is the ratio of the Unemployed and educated male labor force (% of population) of Russian Federation in 2008 to that in 2009?
Provide a succinct answer. 0.94. What is the ratio of the Unemployed and educated male labor force (% of population) in West Bank and Gaza in 2008 to that in 2009?
Your answer should be very brief. 0.94. What is the ratio of the Unemployed and educated male labor force (% of population) in Azerbaijan in 2008 to that in 2010?
Your answer should be compact. 0.56. What is the ratio of the Unemployed and educated male labor force (% of population) of Hong Kong in 2008 to that in 2010?
Offer a terse response. 0.76. What is the ratio of the Unemployed and educated male labor force (% of population) in Russian Federation in 2008 to that in 2010?
Provide a succinct answer. 0.91. What is the ratio of the Unemployed and educated male labor force (% of population) of West Bank and Gaza in 2008 to that in 2010?
Your answer should be very brief. 0.93. What is the ratio of the Unemployed and educated male labor force (% of population) in Azerbaijan in 2008 to that in 2011?
Make the answer very short. 0.87. What is the ratio of the Unemployed and educated male labor force (% of population) of Hong Kong in 2008 to that in 2011?
Your answer should be compact. 1.01. What is the ratio of the Unemployed and educated male labor force (% of population) of Russian Federation in 2008 to that in 2011?
Offer a very short reply. 0.92. What is the ratio of the Unemployed and educated male labor force (% of population) of West Bank and Gaza in 2008 to that in 2011?
Your answer should be compact. 0.81. What is the ratio of the Unemployed and educated male labor force (% of population) in Azerbaijan in 2009 to that in 2010?
Keep it short and to the point. 0.99. What is the ratio of the Unemployed and educated male labor force (% of population) in Russian Federation in 2009 to that in 2010?
Offer a very short reply. 0.98. What is the ratio of the Unemployed and educated male labor force (% of population) in Azerbaijan in 2009 to that in 2011?
Your response must be concise. 1.53. What is the ratio of the Unemployed and educated male labor force (% of population) in Hong Kong in 2009 to that in 2011?
Offer a terse response. 1.21. What is the ratio of the Unemployed and educated male labor force (% of population) in Russian Federation in 2009 to that in 2011?
Give a very brief answer. 0.98. What is the ratio of the Unemployed and educated male labor force (% of population) in West Bank and Gaza in 2009 to that in 2011?
Your answer should be compact. 0.86. What is the ratio of the Unemployed and educated male labor force (% of population) in Azerbaijan in 2010 to that in 2011?
Your answer should be compact. 1.55. What is the ratio of the Unemployed and educated male labor force (% of population) in Hong Kong in 2010 to that in 2011?
Offer a terse response. 1.33. What is the ratio of the Unemployed and educated male labor force (% of population) of West Bank and Gaza in 2010 to that in 2011?
Provide a short and direct response. 0.87. What is the difference between the highest and the lowest Unemployed and educated male labor force (% of population) of Azerbaijan?
Your answer should be compact. 21.3. What is the difference between the highest and the lowest Unemployed and educated male labor force (% of population) in Russian Federation?
Provide a succinct answer. 4.5. What is the difference between the highest and the lowest Unemployed and educated male labor force (% of population) of West Bank and Gaza?
Your response must be concise. 5.1. 